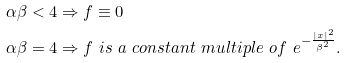<formula> <loc_0><loc_0><loc_500><loc_500>\alpha \beta < 4 & \Rightarrow f \equiv 0 \\ \alpha \beta = 4 & \Rightarrow f \ i s \ a \ c o n s t a n t \ m u l t i p l e \ o f \ e ^ { - \frac { | x | ^ { 2 } } { \beta ^ { 2 } } } .</formula> 